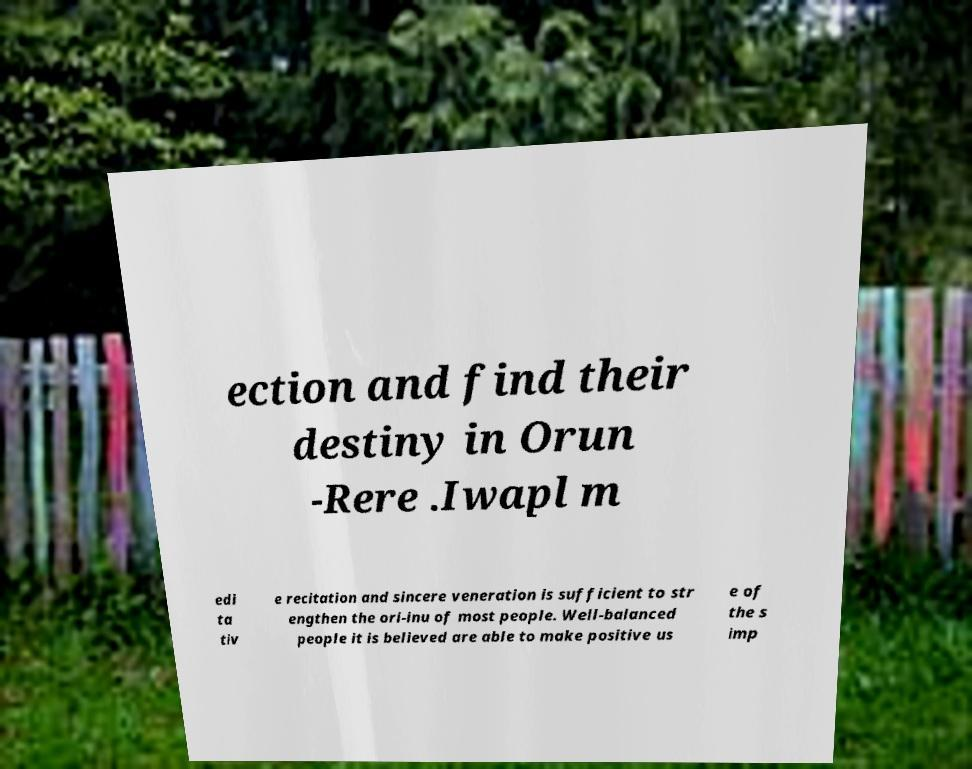There's text embedded in this image that I need extracted. Can you transcribe it verbatim? ection and find their destiny in Orun -Rere .Iwapl m edi ta tiv e recitation and sincere veneration is sufficient to str engthen the ori-inu of most people. Well-balanced people it is believed are able to make positive us e of the s imp 